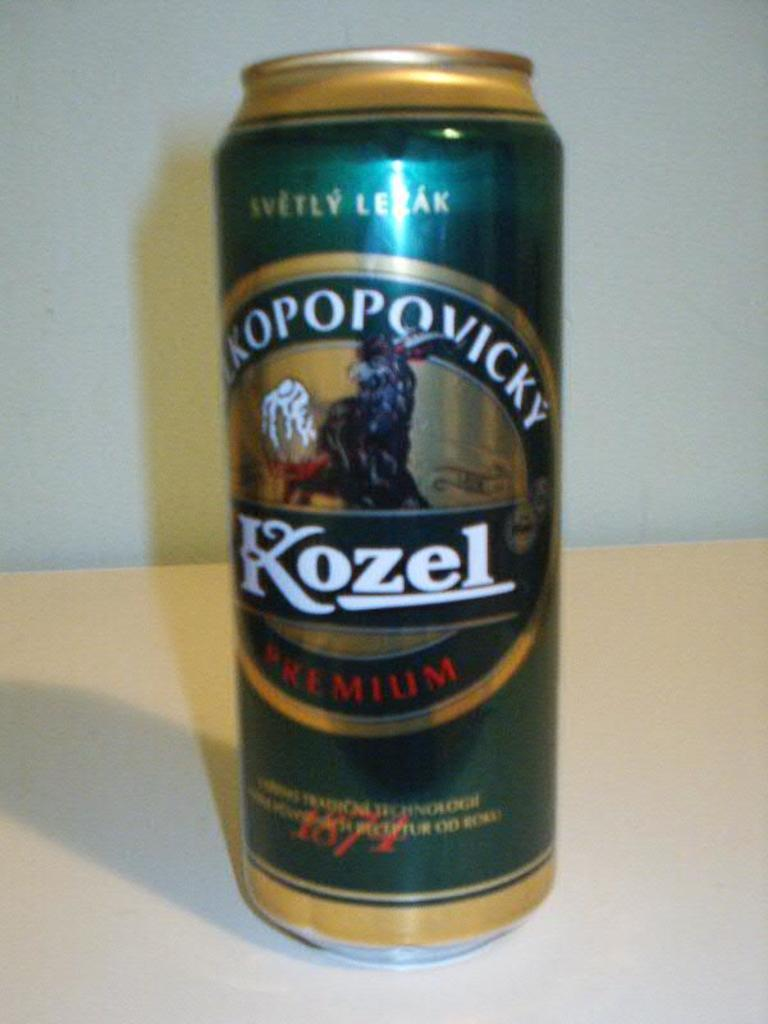Provide a one-sentence caption for the provided image. a large can of Kozel Premium alcohol. 